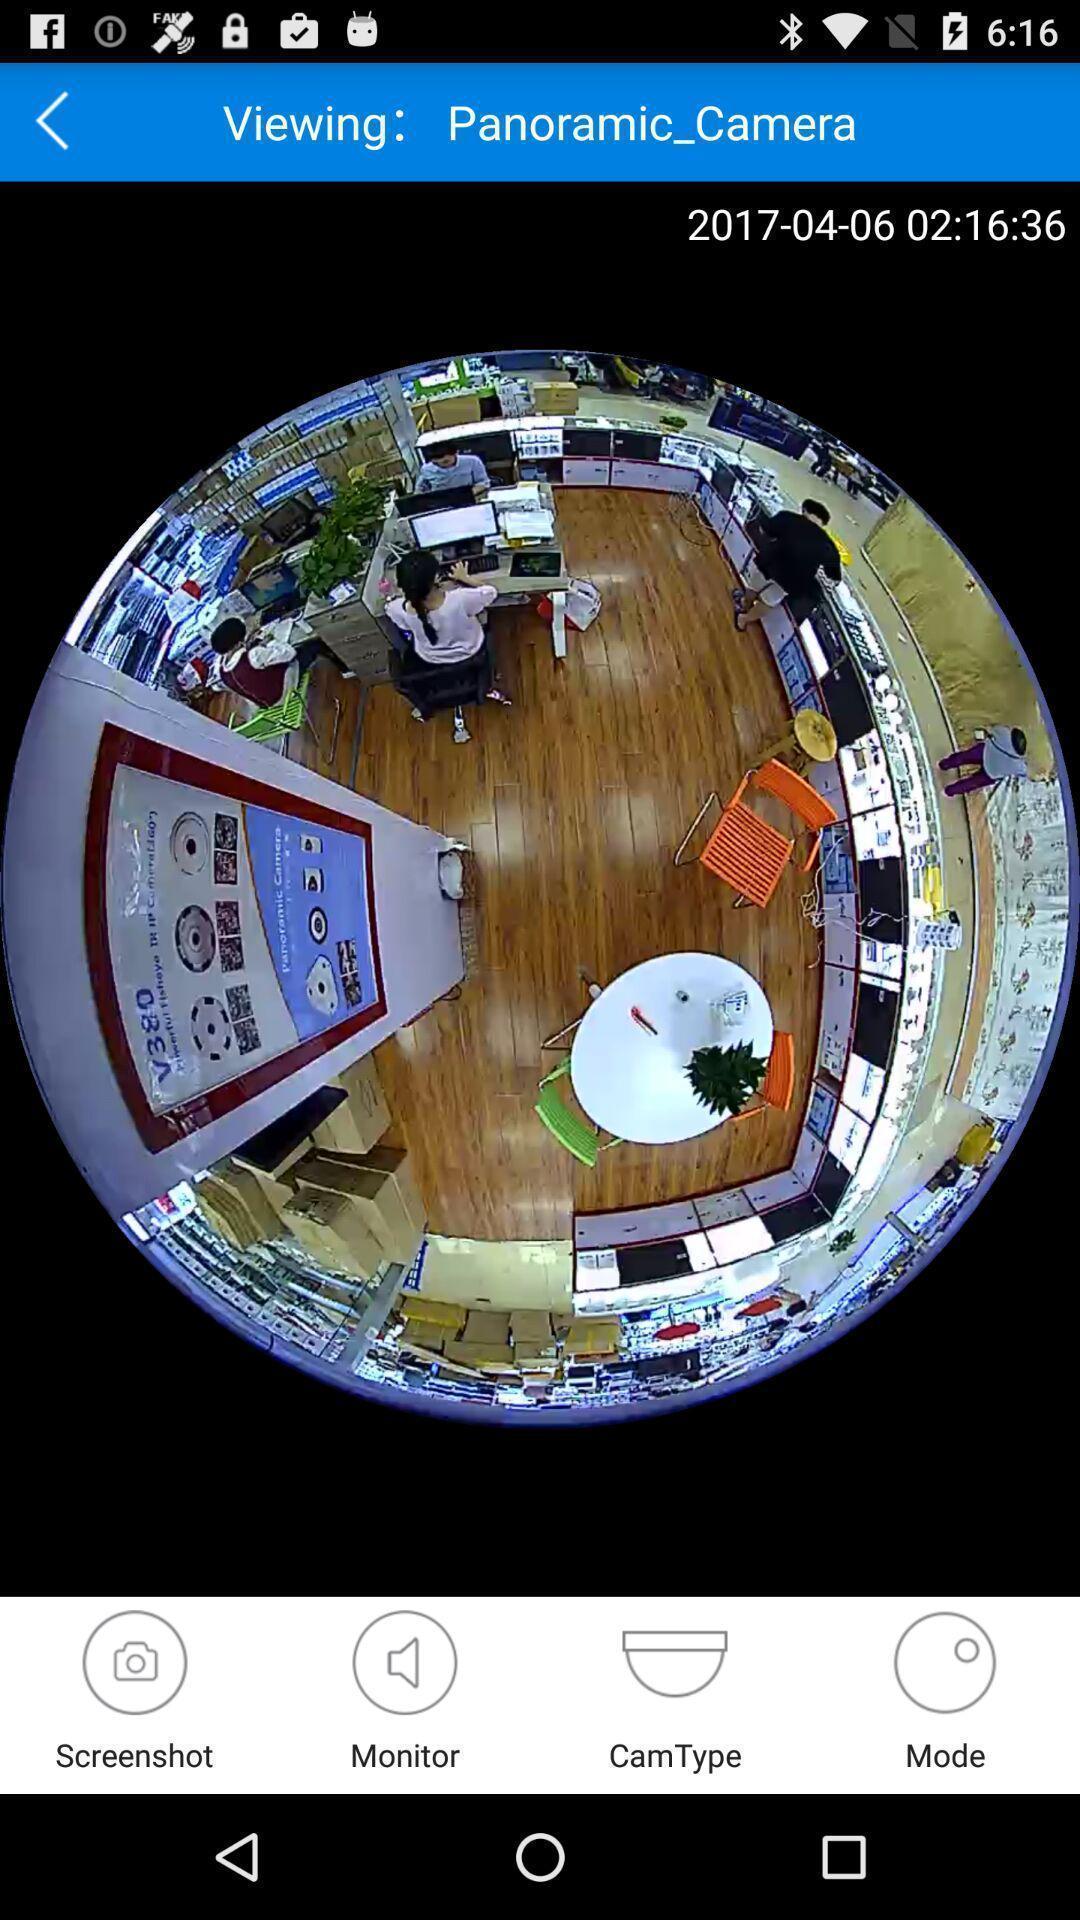Provide a detailed account of this screenshot. Page showing panoramic view on mobile. 